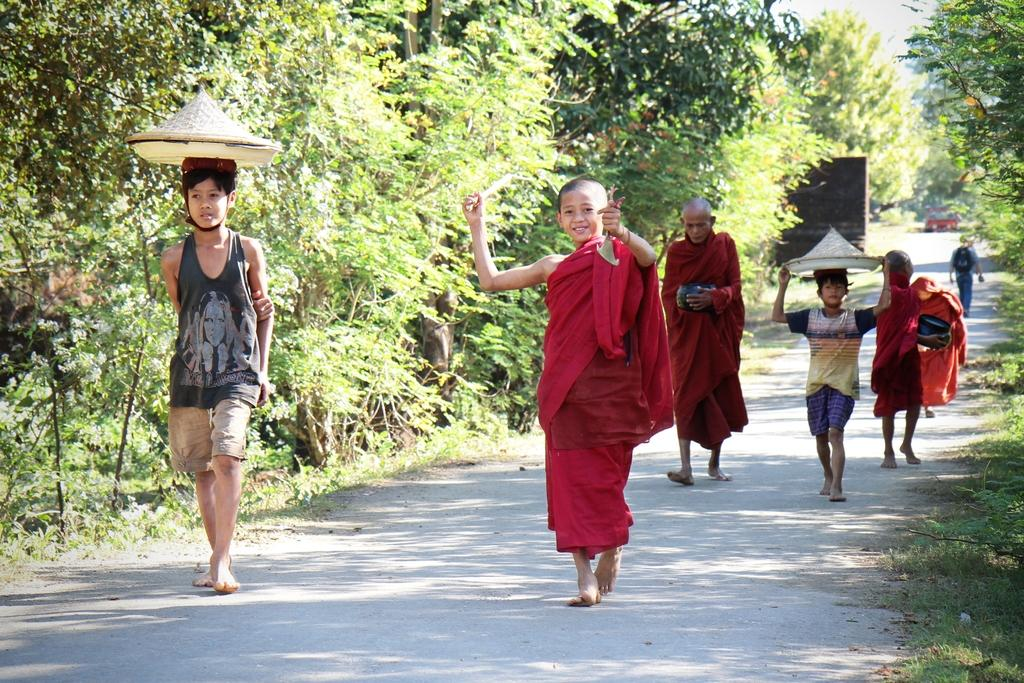What is happening in the image? There is a group of people in the image. Where are the people located? The people are on the road. What can be seen in the background of the image? There are trees in the background of the image. What type of toy can be seen in the hands of the people in the image? There is no toy visible in the hands of the people in the image. 